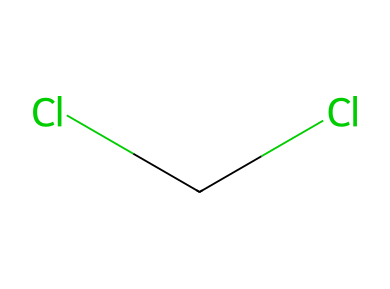How many chlorine atoms are present? The SMILES representation indicates two chlorine atoms (Cl) are attached to the central carbon, which can be counted directly from the structure.
Answer: 2 What type of hybridization is associated with the carbon in this molecule? In the structure, the carbon atom forms two single bonds and has no lone pairs, indicating it has a sp² hybridization, typically found in compounds with a trigonal planar geometry.
Answer: sp² What is the oxidation state of the central carbon atom? The oxidation state of carbon in this structure can be calculated considering its bonds to two chlorine atoms (each -1) and no hydrogens. Thus, it is +2 for carbon in this case.
Answer: +2 What is the simplest name for this chemical compound? The compound is known as dichloroethylene because it consists of two chlorine atoms substituted on a carbon atom with no further complexity.
Answer: dichloroethylene What characteristic of carbenes is demonstrated here? This chemical represents a stable dichlorocarbene due to the presence of substituents providing stability, which is characteristic for many carbenes, especially with halogens.
Answer: stability 